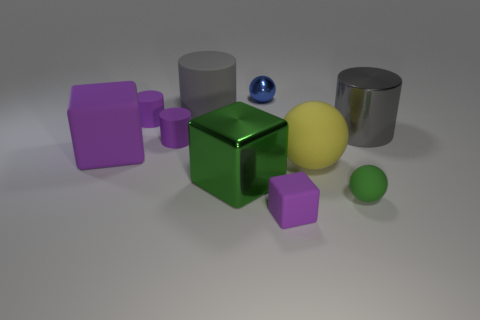How are the objects arranged in the space? The objects are arranged sporadically across a flat surface with no particular pattern. There's a loose grouping near the center consisting of a green metal cube at the heart, surrounded by a yellow plastic sphere, a smaller green plastic sphere, and a couple of purple rubber cubes. Off to the sides, we have the purple rubber cylinder and two metal cylinders - one standing upright and the other lying on its side. 